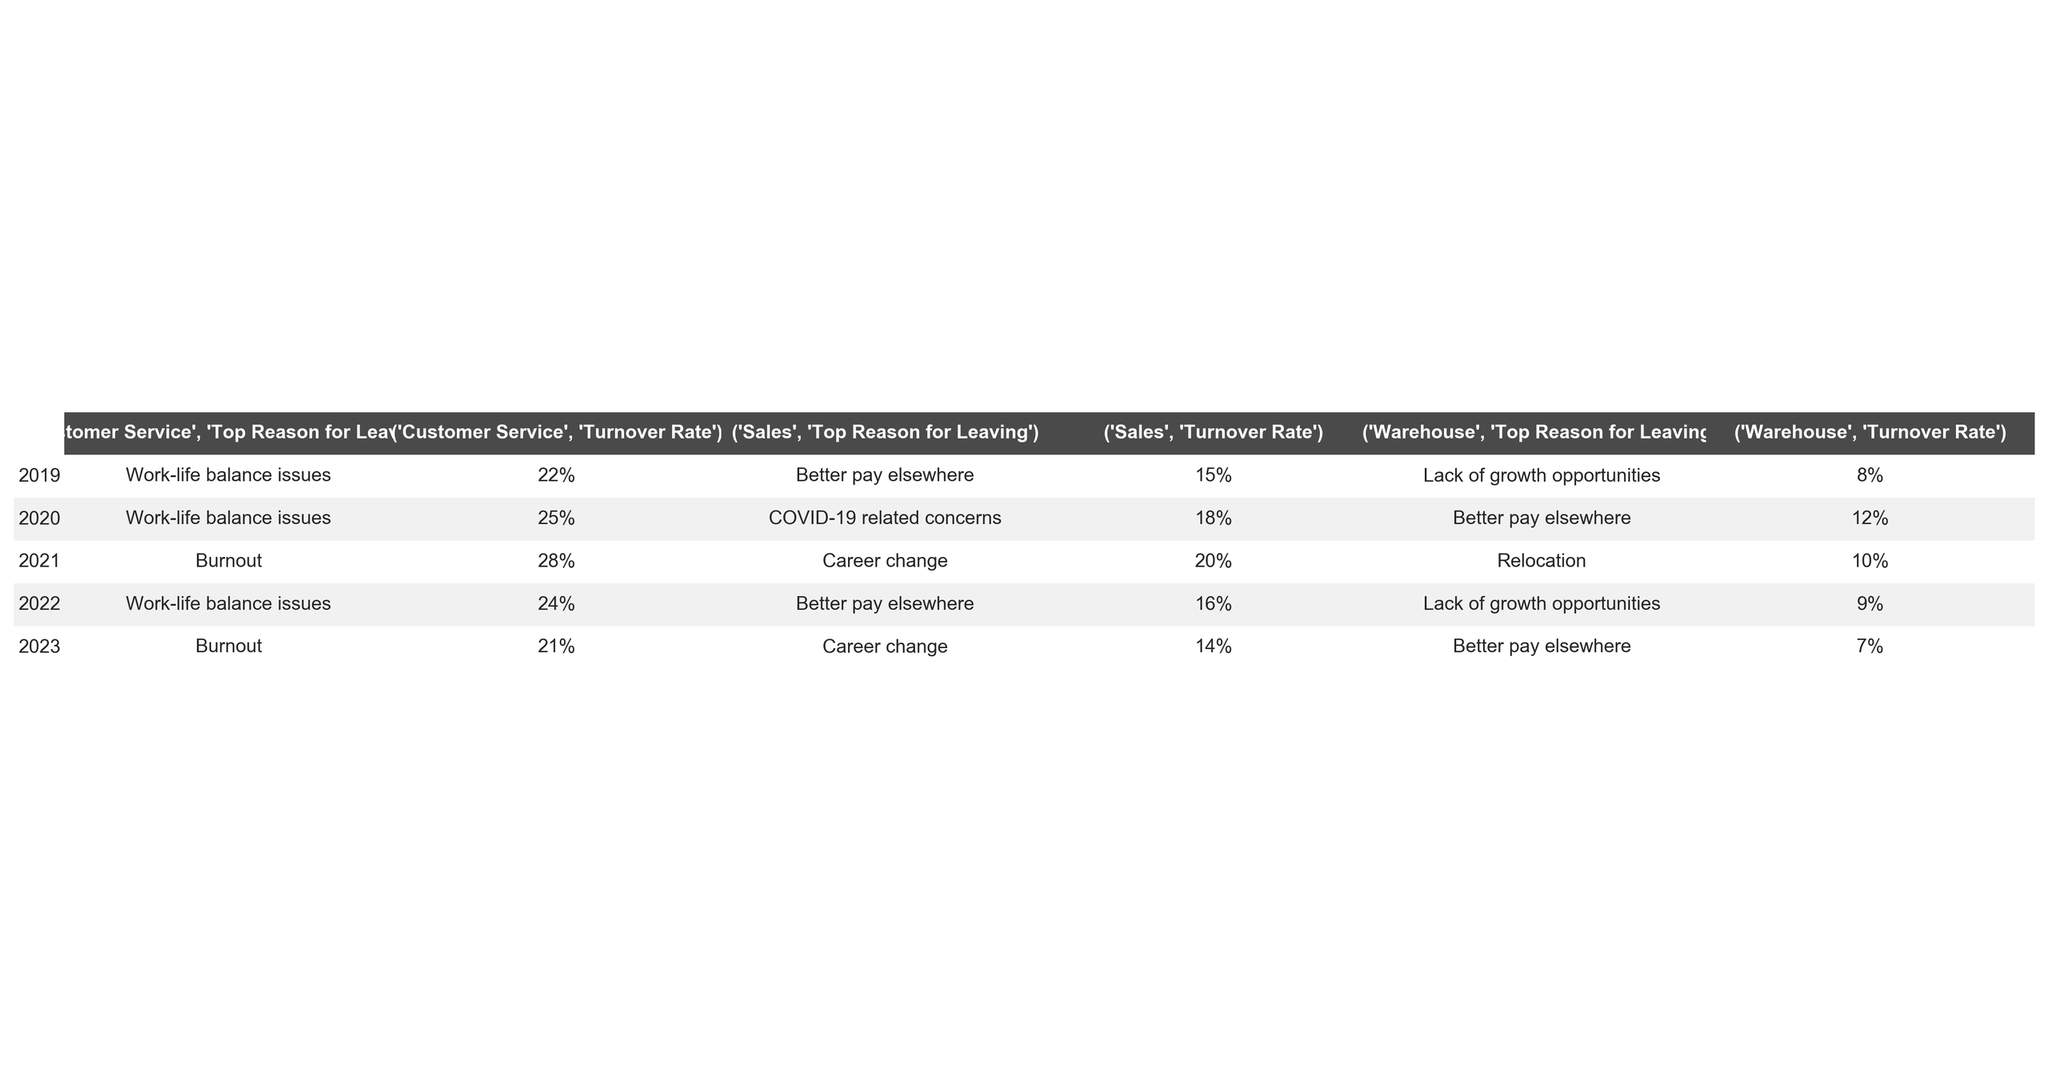What was the turnover rate for the Customer Service department in 2021? The turnover rate for the Customer Service department in 2021 is provided directly in the table as 28%.
Answer: 28% Which year had the highest turnover rate in the Warehouse department? By examining the turnover rates for the Warehouse department across the years, 2020 had the highest rate at 12%.
Answer: 2020 What is the most common reason for leaving in the Sales department across the years? The most common reason for leaving in the Sales department across all listed years is "Better pay elsewhere," which appears for the years 2019, 2022, and 2023.
Answer: Better pay elsewhere What was the average turnover rate for the Customer Service department over the five years? To calculate the average, sum the turnover rates for Customer Service for each year (22% + 25% + 28% + 24% + 21% = 120%) and divide by the number of years (5). The average is 120% / 5 = 24%.
Answer: 24% True or False: The Warehouse department had a lower turnover rate than the Sales department in 2019. In 2019, the turnover rate for the Warehouse department (8%) is lower than for the Sales department (15%), making the statement true.
Answer: True In which year did the Customer Service department have a turnover rate that was 2% less than the previous year? The year 2023 saw a turnover rate of 21%, which is 2% less than the 28% rate in 2022, indicating a decrease of 2%. Therefore, the answer is 2023.
Answer: 2023 What trend can be observed for the turnover rate in the Warehouse department from 2019 to 2023? The turnover rates in the Warehouse department decreased from 8% in 2019 to 7% in 2023, showing a downward trend over the years.
Answer: Decreasing trend What was the top reason for leaving in 2020 across all departments? In 2020, the top reason for leaving in the Sales department was "COVID-19 related concerns," in the Warehouse department was "Better pay elsewhere," and for Customer Service was "Work-life balance issues." Since each department had different reasons, there is no unified top reason for all departments that year.
Answer: No unified top reason What was the difference in turnover rates between the Warehouse department in 2022 and the Sales department in 2023? In 2022, the turnover rate for the Warehouse department was 9%, while for the Sales department in 2023 it was 14%. The difference is 14% - 9% = 5%.
Answer: 5% Was there any year when the turnover rate for Customer Service exceeded 25%? Yes, in 2021, the turnover rate for Customer Service was 28%, which exceeds 25%.
Answer: Yes 